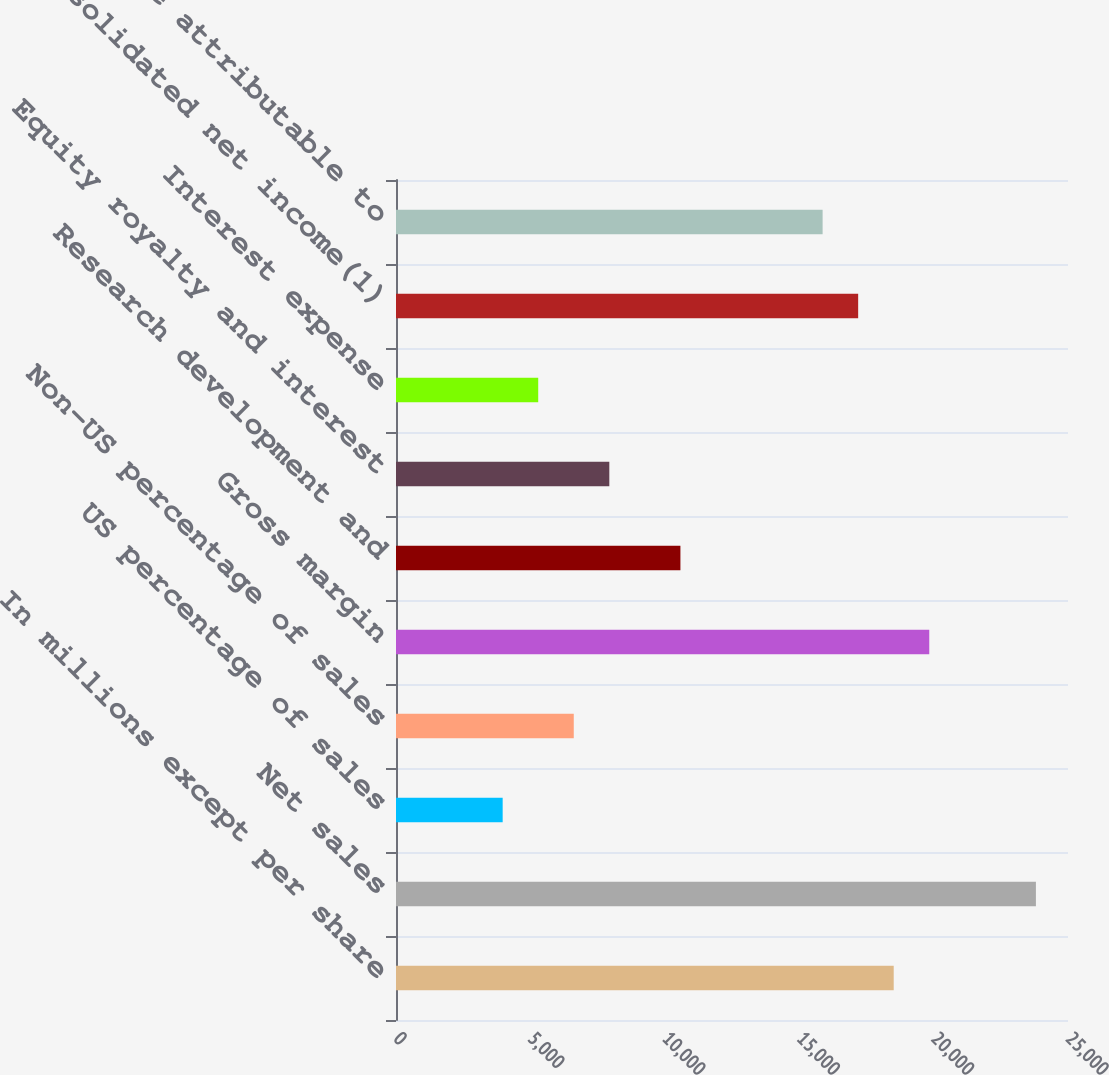Convert chart. <chart><loc_0><loc_0><loc_500><loc_500><bar_chart><fcel>In millions except per share<fcel>Net sales<fcel>US percentage of sales<fcel>Non-US percentage of sales<fcel>Gross margin<fcel>Research development and<fcel>Equity royalty and interest<fcel>Interest expense<fcel>Consolidated net income(1)<fcel>Net income attributable to<nl><fcel>18516<fcel>23806.1<fcel>3968.41<fcel>6613.43<fcel>19838.5<fcel>10581<fcel>7935.94<fcel>5290.92<fcel>17193.5<fcel>15871<nl></chart> 